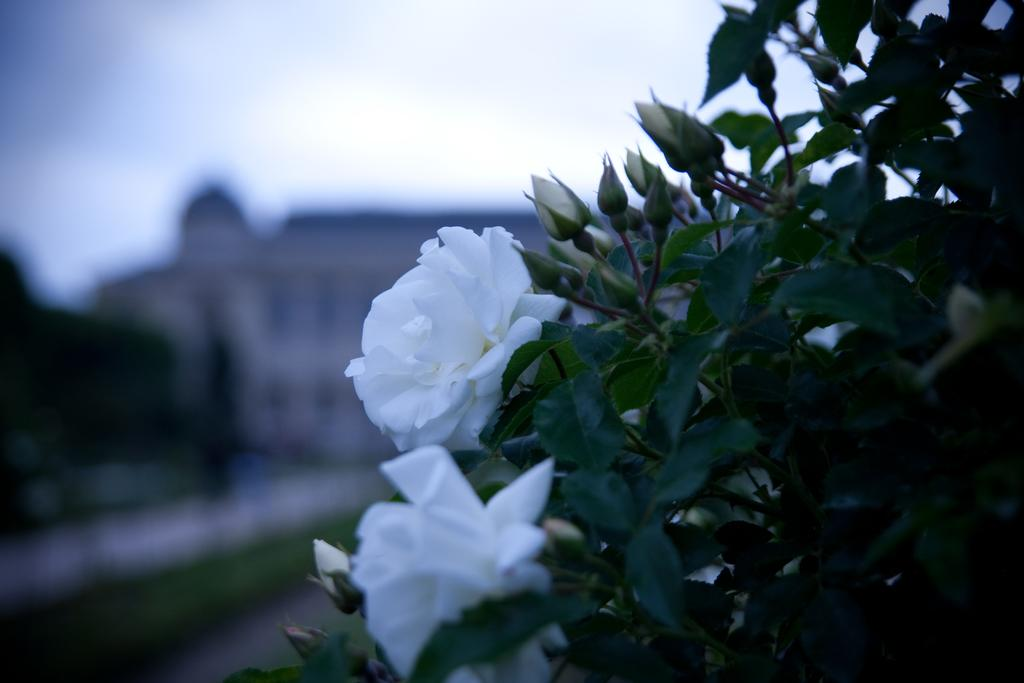What type of plants are visible in the image? There are plants with flowers in the image. What stage of growth are the plants in? The plants have buds. Can you describe the background of the image? The background of the image is blurred. How many hands are visible in the image? There are no hands visible in the image; it features plants with flowers and buds. What color is the silver in the image? There is no silver present in the image. 